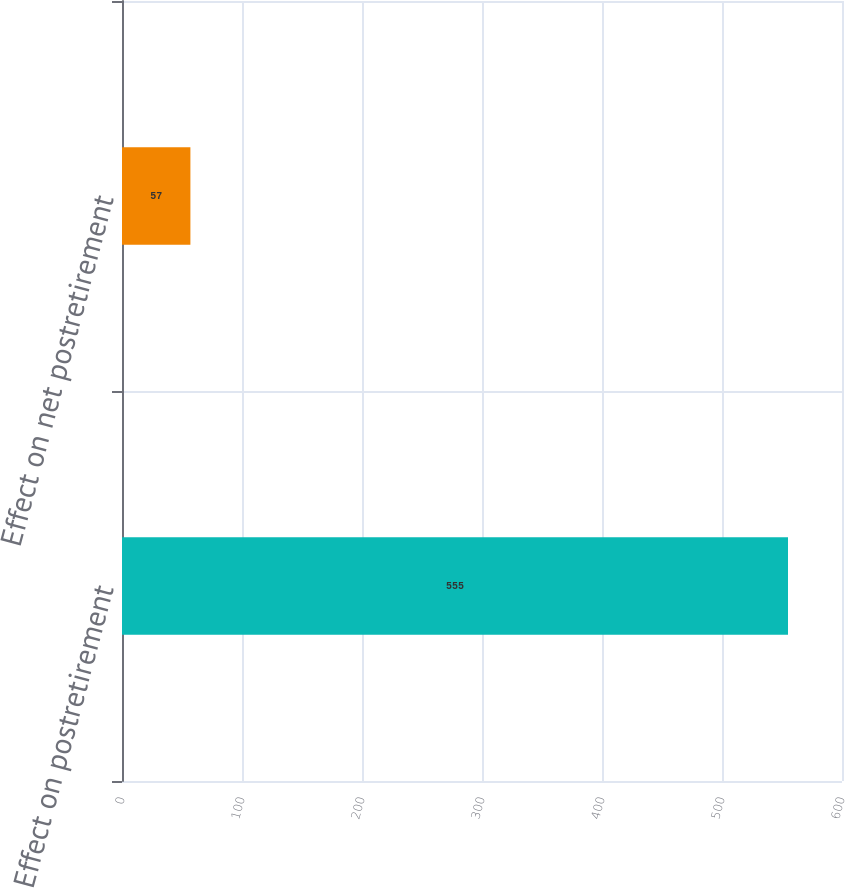<chart> <loc_0><loc_0><loc_500><loc_500><bar_chart><fcel>Effect on postretirement<fcel>Effect on net postretirement<nl><fcel>555<fcel>57<nl></chart> 